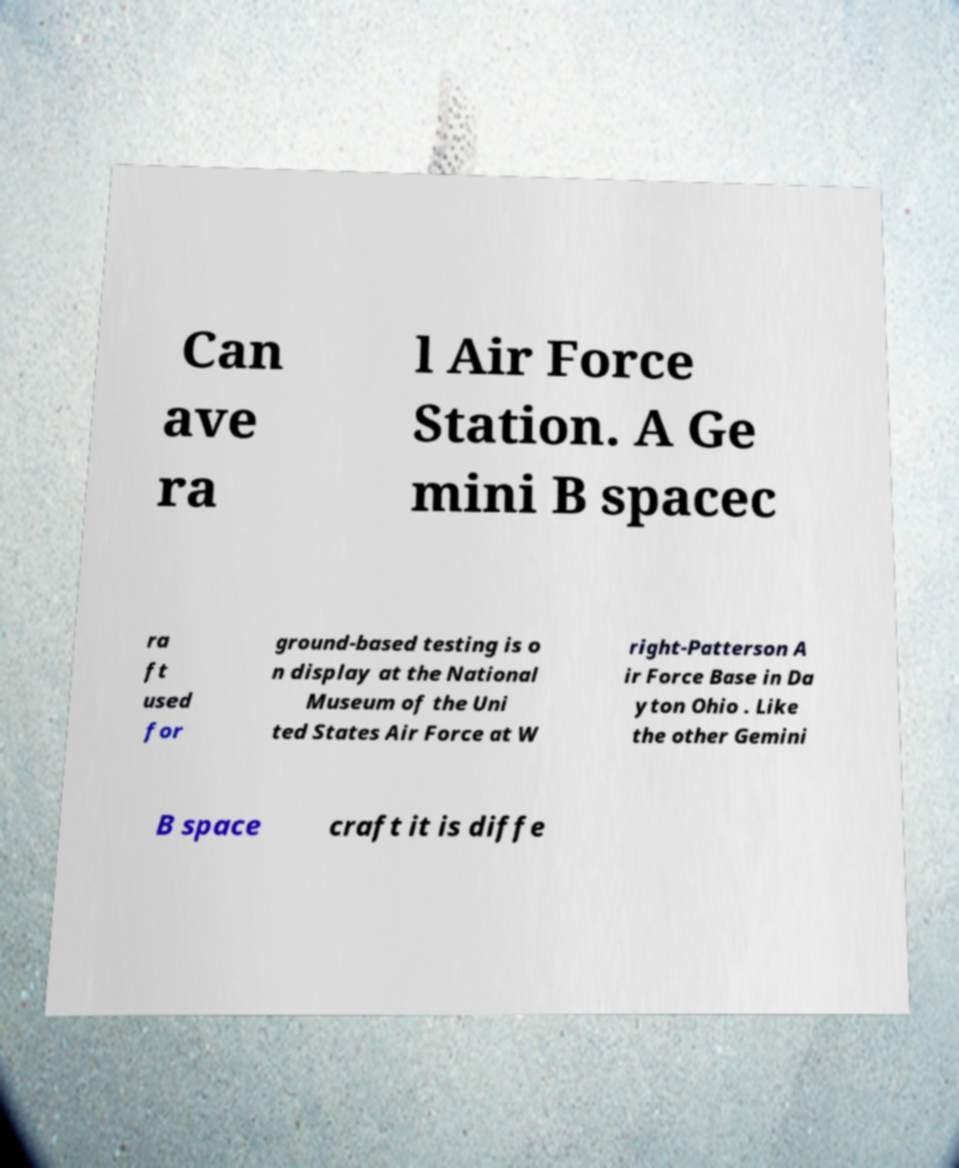Can you accurately transcribe the text from the provided image for me? Can ave ra l Air Force Station. A Ge mini B spacec ra ft used for ground-based testing is o n display at the National Museum of the Uni ted States Air Force at W right-Patterson A ir Force Base in Da yton Ohio . Like the other Gemini B space craft it is diffe 